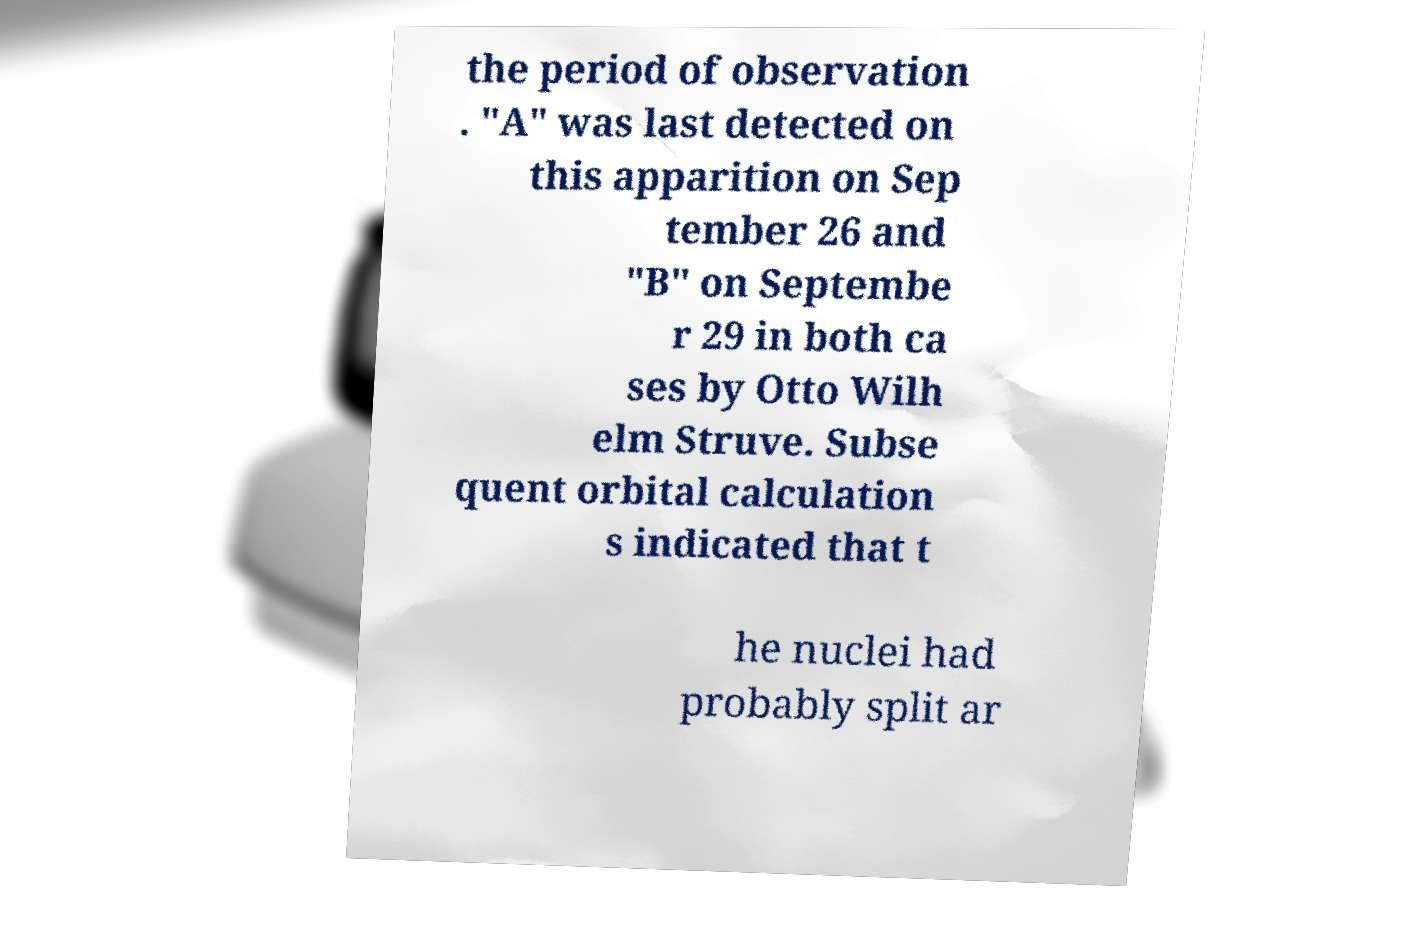What messages or text are displayed in this image? I need them in a readable, typed format. the period of observation . "A" was last detected on this apparition on Sep tember 26 and "B" on Septembe r 29 in both ca ses by Otto Wilh elm Struve. Subse quent orbital calculation s indicated that t he nuclei had probably split ar 